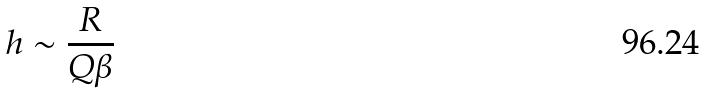Convert formula to latex. <formula><loc_0><loc_0><loc_500><loc_500>h \sim \frac { R } { Q \beta }</formula> 